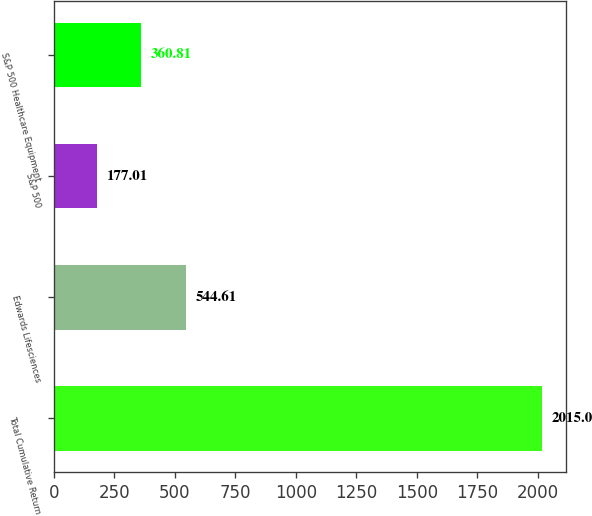Convert chart to OTSL. <chart><loc_0><loc_0><loc_500><loc_500><bar_chart><fcel>Total Cumulative Return<fcel>Edwards Lifesciences<fcel>S&P 500<fcel>S&P 500 Healthcare Equipment<nl><fcel>2015<fcel>544.61<fcel>177.01<fcel>360.81<nl></chart> 